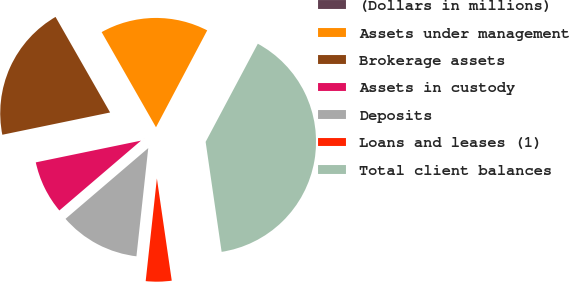<chart> <loc_0><loc_0><loc_500><loc_500><pie_chart><fcel>(Dollars in millions)<fcel>Assets under management<fcel>Brokerage assets<fcel>Assets in custody<fcel>Deposits<fcel>Loans and leases (1)<fcel>Total client balances<nl><fcel>0.04%<fcel>16.0%<fcel>19.99%<fcel>8.02%<fcel>12.01%<fcel>4.03%<fcel>39.93%<nl></chart> 